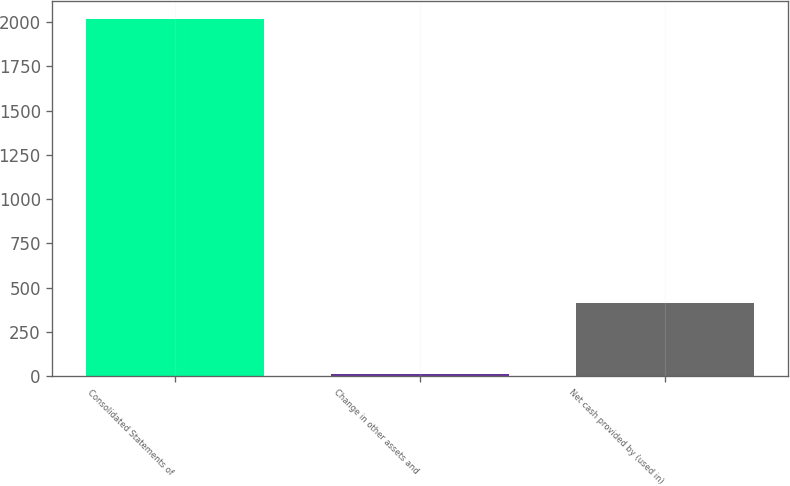<chart> <loc_0><loc_0><loc_500><loc_500><bar_chart><fcel>Consolidated Statements of<fcel>Change in other assets and<fcel>Net cash provided by (used in)<nl><fcel>2015<fcel>11.6<fcel>412.28<nl></chart> 